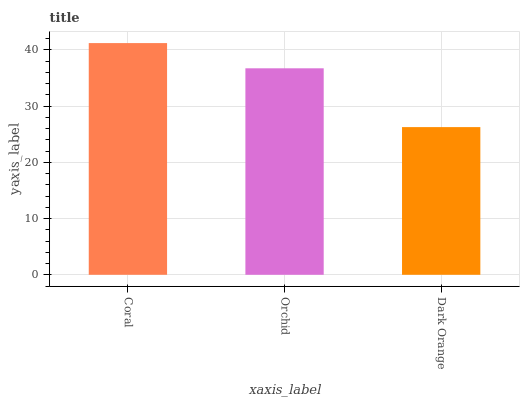Is Dark Orange the minimum?
Answer yes or no. Yes. Is Coral the maximum?
Answer yes or no. Yes. Is Orchid the minimum?
Answer yes or no. No. Is Orchid the maximum?
Answer yes or no. No. Is Coral greater than Orchid?
Answer yes or no. Yes. Is Orchid less than Coral?
Answer yes or no. Yes. Is Orchid greater than Coral?
Answer yes or no. No. Is Coral less than Orchid?
Answer yes or no. No. Is Orchid the high median?
Answer yes or no. Yes. Is Orchid the low median?
Answer yes or no. Yes. Is Coral the high median?
Answer yes or no. No. Is Coral the low median?
Answer yes or no. No. 